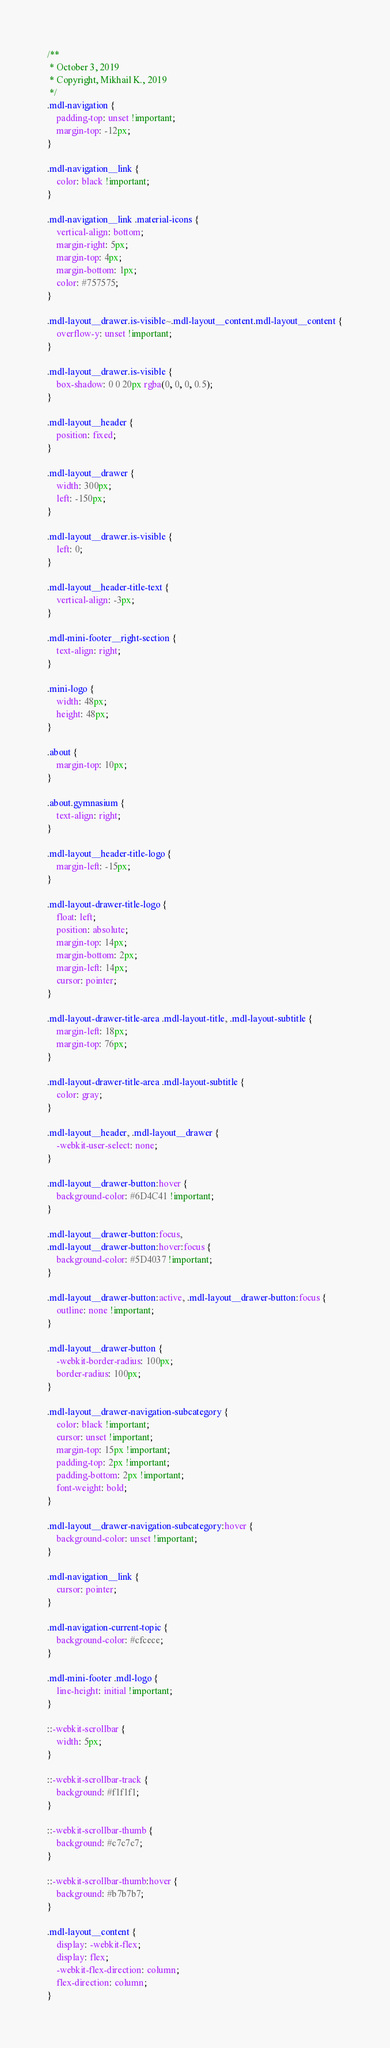<code> <loc_0><loc_0><loc_500><loc_500><_CSS_>/**
 * October 3, 2019
 * Copyright, Mikhail K., 2019
 */
.mdl-navigation {
    padding-top: unset !important;
    margin-top: -12px;
}

.mdl-navigation__link {
    color: black !important;
}

.mdl-navigation__link .material-icons {
    vertical-align: bottom;
    margin-right: 5px;
    margin-top: 4px;
    margin-bottom: 1px;
    color: #757575;
}

.mdl-layout__drawer.is-visible~.mdl-layout__content.mdl-layout__content {
    overflow-y: unset !important;
}

.mdl-layout__drawer.is-visible {
    box-shadow: 0 0 20px rgba(0, 0, 0, 0.5);
}

.mdl-layout__header {
    position: fixed;
}

.mdl-layout__drawer {
    width: 300px;
    left: -150px;
}

.mdl-layout__drawer.is-visible {
    left: 0;
}

.mdl-layout__header-title-text {
    vertical-align: -3px;
}

.mdl-mini-footer__right-section {
    text-align: right;
}

.mini-logo {
    width: 48px;
    height: 48px;
}

.about {
    margin-top: 10px;
}

.about.gymnasium {
    text-align: right;
}

.mdl-layout__header-title-logo {
    margin-left: -15px;
}

.mdl-layout-drawer-title-logo {
    float: left;
    position: absolute;
    margin-top: 14px;
    margin-bottom: 2px;
    margin-left: 14px;
    cursor: pointer;
}

.mdl-layout-drawer-title-area .mdl-layout-title, .mdl-layout-subtitle {
    margin-left: 18px;
    margin-top: 76px;
}

.mdl-layout-drawer-title-area .mdl-layout-subtitle {
    color: gray;
}

.mdl-layout__header, .mdl-layout__drawer {
    -webkit-user-select: none;
}

.mdl-layout__drawer-button:hover {
    background-color: #6D4C41 !important;
}

.mdl-layout__drawer-button:focus,
.mdl-layout__drawer-button:hover:focus {
    background-color: #5D4037 !important;
}

.mdl-layout__drawer-button:active, .mdl-layout__drawer-button:focus {
    outline: none !important;
}

.mdl-layout__drawer-button {
    -webkit-border-radius: 100px;
    border-radius: 100px;
}

.mdl-layout__drawer-navigation-subcategory {
    color: black !important;
    cursor: unset !important;
    margin-top: 15px !important;
    padding-top: 2px !important;
    padding-bottom: 2px !important;
    font-weight: bold;
}

.mdl-layout__drawer-navigation-subcategory:hover {
    background-color: unset !important;
}

.mdl-navigation__link {
    cursor: pointer;
}

.mdl-navigation-current-topic {
    background-color: #cfcece;
}

.mdl-mini-footer .mdl-logo {
    line-height: initial !important;
}

::-webkit-scrollbar {
    width: 5px;
}

::-webkit-scrollbar-track {
    background: #f1f1f1;
}

::-webkit-scrollbar-thumb {
    background: #c7c7c7;
}

::-webkit-scrollbar-thumb:hover {
    background: #b7b7b7;
}

.mdl-layout__content {
    display: -webkit-flex;
    display: flex;
    -webkit-flex-direction: column;
    flex-direction: column;
}</code> 